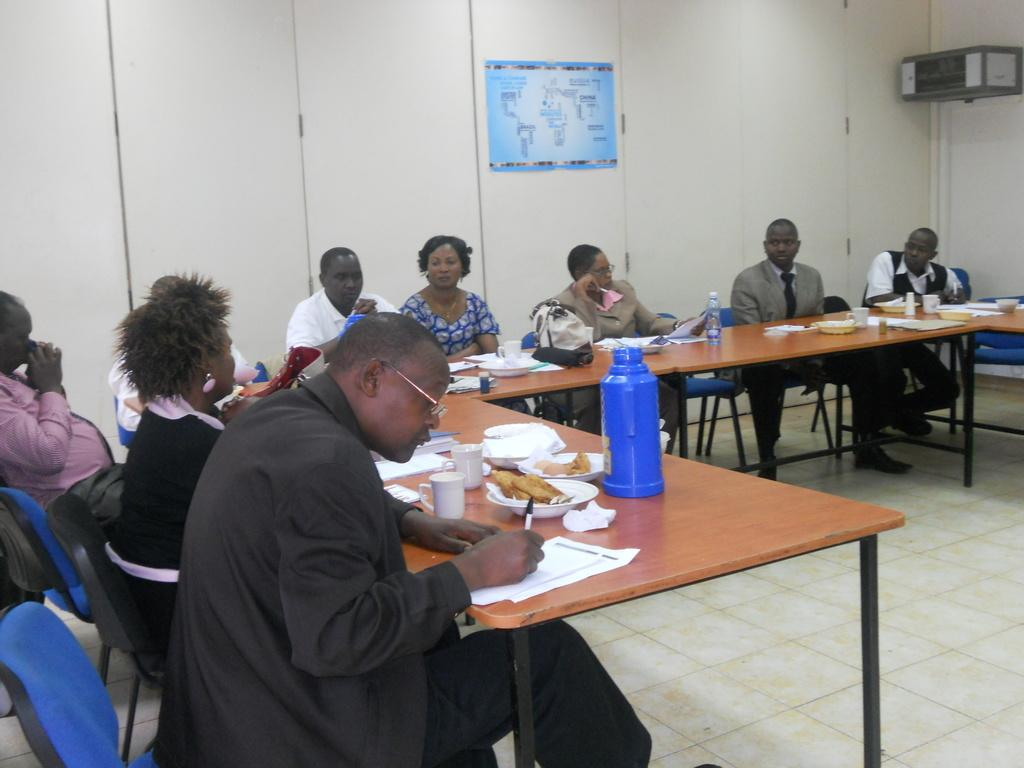What are the people in the image doing? There is a group of people sitting on chairs in the image. Can you describe the man on the left side of the image? The man on the left side of the image is writing on a paper. How does the man change the color of the paper while writing? The man is not changing the color of the paper while writing in the image. The image does not show any indication of the paper changing color. 